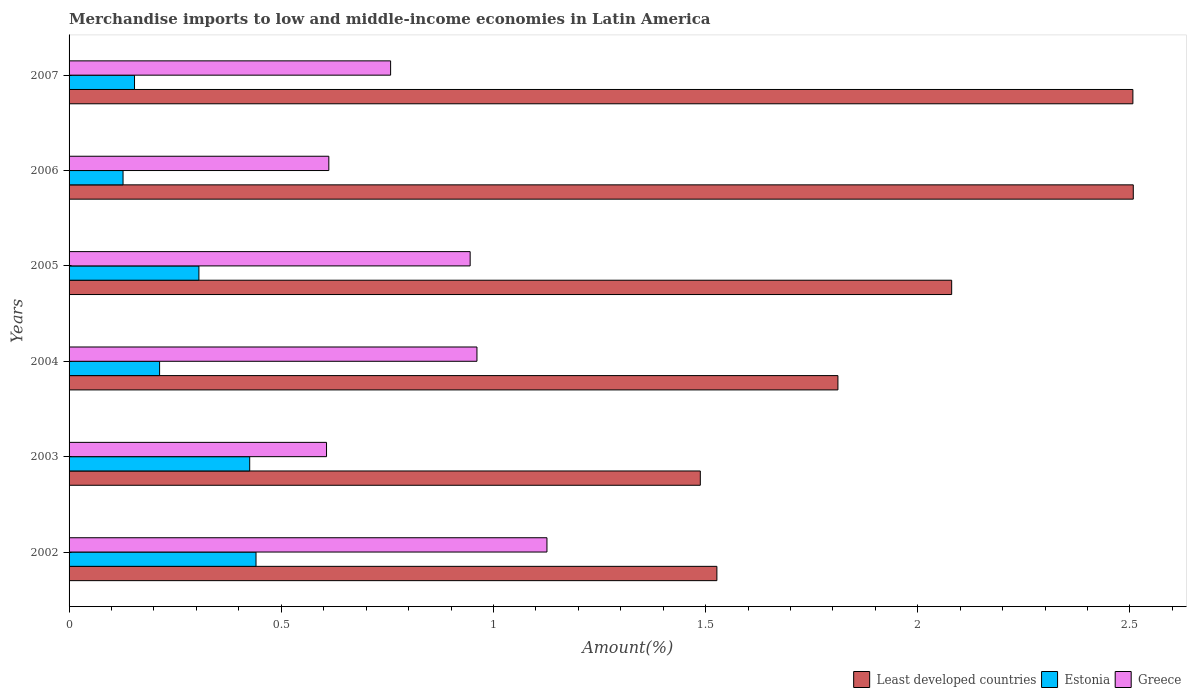How many different coloured bars are there?
Make the answer very short. 3. How many bars are there on the 5th tick from the top?
Make the answer very short. 3. How many bars are there on the 6th tick from the bottom?
Ensure brevity in your answer.  3. In how many cases, is the number of bars for a given year not equal to the number of legend labels?
Provide a short and direct response. 0. What is the percentage of amount earned from merchandise imports in Greece in 2005?
Your response must be concise. 0.95. Across all years, what is the maximum percentage of amount earned from merchandise imports in Estonia?
Give a very brief answer. 0.44. Across all years, what is the minimum percentage of amount earned from merchandise imports in Least developed countries?
Keep it short and to the point. 1.49. What is the total percentage of amount earned from merchandise imports in Least developed countries in the graph?
Offer a very short reply. 11.92. What is the difference between the percentage of amount earned from merchandise imports in Estonia in 2003 and that in 2006?
Keep it short and to the point. 0.3. What is the difference between the percentage of amount earned from merchandise imports in Greece in 2006 and the percentage of amount earned from merchandise imports in Least developed countries in 2007?
Ensure brevity in your answer.  -1.89. What is the average percentage of amount earned from merchandise imports in Greece per year?
Your answer should be very brief. 0.83. In the year 2004, what is the difference between the percentage of amount earned from merchandise imports in Estonia and percentage of amount earned from merchandise imports in Greece?
Keep it short and to the point. -0.75. In how many years, is the percentage of amount earned from merchandise imports in Least developed countries greater than 2.4 %?
Offer a very short reply. 2. What is the ratio of the percentage of amount earned from merchandise imports in Greece in 2002 to that in 2003?
Provide a short and direct response. 1.86. Is the percentage of amount earned from merchandise imports in Greece in 2005 less than that in 2007?
Ensure brevity in your answer.  No. What is the difference between the highest and the second highest percentage of amount earned from merchandise imports in Estonia?
Your answer should be compact. 0.01. What is the difference between the highest and the lowest percentage of amount earned from merchandise imports in Least developed countries?
Give a very brief answer. 1.02. In how many years, is the percentage of amount earned from merchandise imports in Estonia greater than the average percentage of amount earned from merchandise imports in Estonia taken over all years?
Make the answer very short. 3. Is the sum of the percentage of amount earned from merchandise imports in Least developed countries in 2003 and 2006 greater than the maximum percentage of amount earned from merchandise imports in Estonia across all years?
Your response must be concise. Yes. What does the 1st bar from the top in 2003 represents?
Your response must be concise. Greece. What does the 2nd bar from the bottom in 2005 represents?
Your answer should be compact. Estonia. Are all the bars in the graph horizontal?
Your answer should be very brief. Yes. How many years are there in the graph?
Your response must be concise. 6. What is the difference between two consecutive major ticks on the X-axis?
Provide a short and direct response. 0.5. Does the graph contain any zero values?
Provide a short and direct response. No. How many legend labels are there?
Your answer should be very brief. 3. How are the legend labels stacked?
Offer a very short reply. Horizontal. What is the title of the graph?
Ensure brevity in your answer.  Merchandise imports to low and middle-income economies in Latin America. Does "Belgium" appear as one of the legend labels in the graph?
Provide a succinct answer. No. What is the label or title of the X-axis?
Offer a very short reply. Amount(%). What is the label or title of the Y-axis?
Provide a short and direct response. Years. What is the Amount(%) in Least developed countries in 2002?
Make the answer very short. 1.53. What is the Amount(%) in Estonia in 2002?
Your response must be concise. 0.44. What is the Amount(%) of Greece in 2002?
Make the answer very short. 1.13. What is the Amount(%) in Least developed countries in 2003?
Give a very brief answer. 1.49. What is the Amount(%) of Estonia in 2003?
Give a very brief answer. 0.43. What is the Amount(%) in Greece in 2003?
Offer a terse response. 0.61. What is the Amount(%) of Least developed countries in 2004?
Keep it short and to the point. 1.81. What is the Amount(%) in Estonia in 2004?
Your answer should be compact. 0.21. What is the Amount(%) in Greece in 2004?
Provide a short and direct response. 0.96. What is the Amount(%) in Least developed countries in 2005?
Your response must be concise. 2.08. What is the Amount(%) in Estonia in 2005?
Make the answer very short. 0.31. What is the Amount(%) in Greece in 2005?
Provide a succinct answer. 0.95. What is the Amount(%) in Least developed countries in 2006?
Keep it short and to the point. 2.51. What is the Amount(%) in Estonia in 2006?
Give a very brief answer. 0.13. What is the Amount(%) in Greece in 2006?
Keep it short and to the point. 0.61. What is the Amount(%) of Least developed countries in 2007?
Provide a succinct answer. 2.51. What is the Amount(%) in Estonia in 2007?
Ensure brevity in your answer.  0.15. What is the Amount(%) of Greece in 2007?
Make the answer very short. 0.76. Across all years, what is the maximum Amount(%) in Least developed countries?
Keep it short and to the point. 2.51. Across all years, what is the maximum Amount(%) of Estonia?
Your answer should be very brief. 0.44. Across all years, what is the maximum Amount(%) in Greece?
Make the answer very short. 1.13. Across all years, what is the minimum Amount(%) in Least developed countries?
Keep it short and to the point. 1.49. Across all years, what is the minimum Amount(%) of Estonia?
Offer a very short reply. 0.13. Across all years, what is the minimum Amount(%) in Greece?
Provide a short and direct response. 0.61. What is the total Amount(%) in Least developed countries in the graph?
Your answer should be compact. 11.92. What is the total Amount(%) of Estonia in the graph?
Your answer should be very brief. 1.67. What is the total Amount(%) of Greece in the graph?
Provide a short and direct response. 5.01. What is the difference between the Amount(%) in Least developed countries in 2002 and that in 2003?
Your response must be concise. 0.04. What is the difference between the Amount(%) in Estonia in 2002 and that in 2003?
Make the answer very short. 0.01. What is the difference between the Amount(%) of Greece in 2002 and that in 2003?
Your answer should be very brief. 0.52. What is the difference between the Amount(%) of Least developed countries in 2002 and that in 2004?
Your response must be concise. -0.29. What is the difference between the Amount(%) of Estonia in 2002 and that in 2004?
Give a very brief answer. 0.23. What is the difference between the Amount(%) in Greece in 2002 and that in 2004?
Give a very brief answer. 0.17. What is the difference between the Amount(%) in Least developed countries in 2002 and that in 2005?
Keep it short and to the point. -0.55. What is the difference between the Amount(%) of Estonia in 2002 and that in 2005?
Your response must be concise. 0.13. What is the difference between the Amount(%) in Greece in 2002 and that in 2005?
Provide a succinct answer. 0.18. What is the difference between the Amount(%) in Least developed countries in 2002 and that in 2006?
Ensure brevity in your answer.  -0.98. What is the difference between the Amount(%) of Estonia in 2002 and that in 2006?
Your answer should be very brief. 0.31. What is the difference between the Amount(%) of Greece in 2002 and that in 2006?
Provide a succinct answer. 0.51. What is the difference between the Amount(%) in Least developed countries in 2002 and that in 2007?
Your response must be concise. -0.98. What is the difference between the Amount(%) in Estonia in 2002 and that in 2007?
Provide a succinct answer. 0.29. What is the difference between the Amount(%) of Greece in 2002 and that in 2007?
Give a very brief answer. 0.37. What is the difference between the Amount(%) of Least developed countries in 2003 and that in 2004?
Your response must be concise. -0.32. What is the difference between the Amount(%) in Estonia in 2003 and that in 2004?
Your response must be concise. 0.21. What is the difference between the Amount(%) in Greece in 2003 and that in 2004?
Your answer should be very brief. -0.35. What is the difference between the Amount(%) in Least developed countries in 2003 and that in 2005?
Offer a terse response. -0.59. What is the difference between the Amount(%) of Estonia in 2003 and that in 2005?
Offer a terse response. 0.12. What is the difference between the Amount(%) in Greece in 2003 and that in 2005?
Give a very brief answer. -0.34. What is the difference between the Amount(%) in Least developed countries in 2003 and that in 2006?
Your answer should be compact. -1.02. What is the difference between the Amount(%) in Estonia in 2003 and that in 2006?
Make the answer very short. 0.3. What is the difference between the Amount(%) of Greece in 2003 and that in 2006?
Make the answer very short. -0.01. What is the difference between the Amount(%) in Least developed countries in 2003 and that in 2007?
Your response must be concise. -1.02. What is the difference between the Amount(%) of Estonia in 2003 and that in 2007?
Provide a short and direct response. 0.27. What is the difference between the Amount(%) in Greece in 2003 and that in 2007?
Offer a very short reply. -0.15. What is the difference between the Amount(%) in Least developed countries in 2004 and that in 2005?
Give a very brief answer. -0.27. What is the difference between the Amount(%) in Estonia in 2004 and that in 2005?
Provide a succinct answer. -0.09. What is the difference between the Amount(%) of Greece in 2004 and that in 2005?
Provide a succinct answer. 0.02. What is the difference between the Amount(%) of Least developed countries in 2004 and that in 2006?
Provide a short and direct response. -0.7. What is the difference between the Amount(%) in Estonia in 2004 and that in 2006?
Give a very brief answer. 0.09. What is the difference between the Amount(%) in Greece in 2004 and that in 2006?
Offer a very short reply. 0.35. What is the difference between the Amount(%) of Least developed countries in 2004 and that in 2007?
Offer a terse response. -0.7. What is the difference between the Amount(%) of Estonia in 2004 and that in 2007?
Keep it short and to the point. 0.06. What is the difference between the Amount(%) of Greece in 2004 and that in 2007?
Provide a short and direct response. 0.2. What is the difference between the Amount(%) of Least developed countries in 2005 and that in 2006?
Provide a succinct answer. -0.43. What is the difference between the Amount(%) of Estonia in 2005 and that in 2006?
Provide a succinct answer. 0.18. What is the difference between the Amount(%) in Greece in 2005 and that in 2006?
Your answer should be compact. 0.33. What is the difference between the Amount(%) of Least developed countries in 2005 and that in 2007?
Your response must be concise. -0.43. What is the difference between the Amount(%) of Estonia in 2005 and that in 2007?
Offer a very short reply. 0.15. What is the difference between the Amount(%) of Greece in 2005 and that in 2007?
Your answer should be very brief. 0.19. What is the difference between the Amount(%) of Least developed countries in 2006 and that in 2007?
Give a very brief answer. 0. What is the difference between the Amount(%) of Estonia in 2006 and that in 2007?
Your answer should be very brief. -0.03. What is the difference between the Amount(%) in Greece in 2006 and that in 2007?
Offer a very short reply. -0.15. What is the difference between the Amount(%) in Least developed countries in 2002 and the Amount(%) in Estonia in 2003?
Make the answer very short. 1.1. What is the difference between the Amount(%) of Least developed countries in 2002 and the Amount(%) of Greece in 2003?
Your answer should be very brief. 0.92. What is the difference between the Amount(%) in Estonia in 2002 and the Amount(%) in Greece in 2003?
Ensure brevity in your answer.  -0.17. What is the difference between the Amount(%) of Least developed countries in 2002 and the Amount(%) of Estonia in 2004?
Offer a terse response. 1.31. What is the difference between the Amount(%) in Least developed countries in 2002 and the Amount(%) in Greece in 2004?
Keep it short and to the point. 0.57. What is the difference between the Amount(%) of Estonia in 2002 and the Amount(%) of Greece in 2004?
Provide a succinct answer. -0.52. What is the difference between the Amount(%) of Least developed countries in 2002 and the Amount(%) of Estonia in 2005?
Your response must be concise. 1.22. What is the difference between the Amount(%) in Least developed countries in 2002 and the Amount(%) in Greece in 2005?
Make the answer very short. 0.58. What is the difference between the Amount(%) of Estonia in 2002 and the Amount(%) of Greece in 2005?
Keep it short and to the point. -0.5. What is the difference between the Amount(%) of Least developed countries in 2002 and the Amount(%) of Estonia in 2006?
Your answer should be very brief. 1.4. What is the difference between the Amount(%) of Least developed countries in 2002 and the Amount(%) of Greece in 2006?
Provide a short and direct response. 0.91. What is the difference between the Amount(%) of Estonia in 2002 and the Amount(%) of Greece in 2006?
Offer a very short reply. -0.17. What is the difference between the Amount(%) in Least developed countries in 2002 and the Amount(%) in Estonia in 2007?
Make the answer very short. 1.37. What is the difference between the Amount(%) of Least developed countries in 2002 and the Amount(%) of Greece in 2007?
Make the answer very short. 0.77. What is the difference between the Amount(%) of Estonia in 2002 and the Amount(%) of Greece in 2007?
Provide a short and direct response. -0.32. What is the difference between the Amount(%) of Least developed countries in 2003 and the Amount(%) of Estonia in 2004?
Your answer should be very brief. 1.27. What is the difference between the Amount(%) in Least developed countries in 2003 and the Amount(%) in Greece in 2004?
Give a very brief answer. 0.53. What is the difference between the Amount(%) of Estonia in 2003 and the Amount(%) of Greece in 2004?
Your response must be concise. -0.54. What is the difference between the Amount(%) of Least developed countries in 2003 and the Amount(%) of Estonia in 2005?
Keep it short and to the point. 1.18. What is the difference between the Amount(%) in Least developed countries in 2003 and the Amount(%) in Greece in 2005?
Offer a terse response. 0.54. What is the difference between the Amount(%) in Estonia in 2003 and the Amount(%) in Greece in 2005?
Make the answer very short. -0.52. What is the difference between the Amount(%) of Least developed countries in 2003 and the Amount(%) of Estonia in 2006?
Your answer should be very brief. 1.36. What is the difference between the Amount(%) in Least developed countries in 2003 and the Amount(%) in Greece in 2006?
Offer a very short reply. 0.88. What is the difference between the Amount(%) of Estonia in 2003 and the Amount(%) of Greece in 2006?
Make the answer very short. -0.19. What is the difference between the Amount(%) in Least developed countries in 2003 and the Amount(%) in Greece in 2007?
Offer a very short reply. 0.73. What is the difference between the Amount(%) in Estonia in 2003 and the Amount(%) in Greece in 2007?
Ensure brevity in your answer.  -0.33. What is the difference between the Amount(%) in Least developed countries in 2004 and the Amount(%) in Estonia in 2005?
Offer a very short reply. 1.51. What is the difference between the Amount(%) of Least developed countries in 2004 and the Amount(%) of Greece in 2005?
Your response must be concise. 0.87. What is the difference between the Amount(%) in Estonia in 2004 and the Amount(%) in Greece in 2005?
Your answer should be very brief. -0.73. What is the difference between the Amount(%) of Least developed countries in 2004 and the Amount(%) of Estonia in 2006?
Keep it short and to the point. 1.68. What is the difference between the Amount(%) of Least developed countries in 2004 and the Amount(%) of Greece in 2006?
Ensure brevity in your answer.  1.2. What is the difference between the Amount(%) in Estonia in 2004 and the Amount(%) in Greece in 2006?
Your answer should be compact. -0.4. What is the difference between the Amount(%) of Least developed countries in 2004 and the Amount(%) of Estonia in 2007?
Your response must be concise. 1.66. What is the difference between the Amount(%) in Least developed countries in 2004 and the Amount(%) in Greece in 2007?
Provide a succinct answer. 1.05. What is the difference between the Amount(%) in Estonia in 2004 and the Amount(%) in Greece in 2007?
Give a very brief answer. -0.54. What is the difference between the Amount(%) in Least developed countries in 2005 and the Amount(%) in Estonia in 2006?
Offer a very short reply. 1.95. What is the difference between the Amount(%) of Least developed countries in 2005 and the Amount(%) of Greece in 2006?
Your answer should be compact. 1.47. What is the difference between the Amount(%) of Estonia in 2005 and the Amount(%) of Greece in 2006?
Provide a short and direct response. -0.31. What is the difference between the Amount(%) of Least developed countries in 2005 and the Amount(%) of Estonia in 2007?
Offer a very short reply. 1.93. What is the difference between the Amount(%) in Least developed countries in 2005 and the Amount(%) in Greece in 2007?
Your response must be concise. 1.32. What is the difference between the Amount(%) of Estonia in 2005 and the Amount(%) of Greece in 2007?
Your response must be concise. -0.45. What is the difference between the Amount(%) in Least developed countries in 2006 and the Amount(%) in Estonia in 2007?
Make the answer very short. 2.35. What is the difference between the Amount(%) of Least developed countries in 2006 and the Amount(%) of Greece in 2007?
Offer a terse response. 1.75. What is the difference between the Amount(%) in Estonia in 2006 and the Amount(%) in Greece in 2007?
Provide a short and direct response. -0.63. What is the average Amount(%) of Least developed countries per year?
Your answer should be very brief. 1.99. What is the average Amount(%) of Estonia per year?
Offer a very short reply. 0.28. What is the average Amount(%) in Greece per year?
Keep it short and to the point. 0.83. In the year 2002, what is the difference between the Amount(%) in Least developed countries and Amount(%) in Estonia?
Your answer should be very brief. 1.09. In the year 2002, what is the difference between the Amount(%) of Least developed countries and Amount(%) of Greece?
Offer a terse response. 0.4. In the year 2002, what is the difference between the Amount(%) in Estonia and Amount(%) in Greece?
Give a very brief answer. -0.69. In the year 2003, what is the difference between the Amount(%) in Least developed countries and Amount(%) in Estonia?
Offer a terse response. 1.06. In the year 2003, what is the difference between the Amount(%) of Least developed countries and Amount(%) of Greece?
Provide a short and direct response. 0.88. In the year 2003, what is the difference between the Amount(%) of Estonia and Amount(%) of Greece?
Your answer should be very brief. -0.18. In the year 2004, what is the difference between the Amount(%) in Least developed countries and Amount(%) in Estonia?
Provide a short and direct response. 1.6. In the year 2004, what is the difference between the Amount(%) in Least developed countries and Amount(%) in Greece?
Your response must be concise. 0.85. In the year 2004, what is the difference between the Amount(%) in Estonia and Amount(%) in Greece?
Your response must be concise. -0.75. In the year 2005, what is the difference between the Amount(%) of Least developed countries and Amount(%) of Estonia?
Provide a succinct answer. 1.77. In the year 2005, what is the difference between the Amount(%) of Least developed countries and Amount(%) of Greece?
Provide a short and direct response. 1.13. In the year 2005, what is the difference between the Amount(%) in Estonia and Amount(%) in Greece?
Offer a very short reply. -0.64. In the year 2006, what is the difference between the Amount(%) in Least developed countries and Amount(%) in Estonia?
Offer a very short reply. 2.38. In the year 2006, what is the difference between the Amount(%) of Least developed countries and Amount(%) of Greece?
Your answer should be very brief. 1.9. In the year 2006, what is the difference between the Amount(%) of Estonia and Amount(%) of Greece?
Provide a succinct answer. -0.48. In the year 2007, what is the difference between the Amount(%) of Least developed countries and Amount(%) of Estonia?
Your answer should be very brief. 2.35. In the year 2007, what is the difference between the Amount(%) of Least developed countries and Amount(%) of Greece?
Keep it short and to the point. 1.75. In the year 2007, what is the difference between the Amount(%) in Estonia and Amount(%) in Greece?
Your answer should be compact. -0.6. What is the ratio of the Amount(%) of Least developed countries in 2002 to that in 2003?
Your answer should be very brief. 1.03. What is the ratio of the Amount(%) in Estonia in 2002 to that in 2003?
Give a very brief answer. 1.03. What is the ratio of the Amount(%) of Greece in 2002 to that in 2003?
Ensure brevity in your answer.  1.86. What is the ratio of the Amount(%) of Least developed countries in 2002 to that in 2004?
Your response must be concise. 0.84. What is the ratio of the Amount(%) in Estonia in 2002 to that in 2004?
Offer a very short reply. 2.07. What is the ratio of the Amount(%) in Greece in 2002 to that in 2004?
Provide a succinct answer. 1.17. What is the ratio of the Amount(%) of Least developed countries in 2002 to that in 2005?
Offer a very short reply. 0.73. What is the ratio of the Amount(%) in Estonia in 2002 to that in 2005?
Offer a very short reply. 1.44. What is the ratio of the Amount(%) in Greece in 2002 to that in 2005?
Your answer should be compact. 1.19. What is the ratio of the Amount(%) in Least developed countries in 2002 to that in 2006?
Make the answer very short. 0.61. What is the ratio of the Amount(%) of Estonia in 2002 to that in 2006?
Your answer should be compact. 3.46. What is the ratio of the Amount(%) of Greece in 2002 to that in 2006?
Keep it short and to the point. 1.84. What is the ratio of the Amount(%) of Least developed countries in 2002 to that in 2007?
Your response must be concise. 0.61. What is the ratio of the Amount(%) of Estonia in 2002 to that in 2007?
Offer a terse response. 2.86. What is the ratio of the Amount(%) in Greece in 2002 to that in 2007?
Keep it short and to the point. 1.49. What is the ratio of the Amount(%) of Least developed countries in 2003 to that in 2004?
Keep it short and to the point. 0.82. What is the ratio of the Amount(%) in Estonia in 2003 to that in 2004?
Your answer should be very brief. 2. What is the ratio of the Amount(%) in Greece in 2003 to that in 2004?
Ensure brevity in your answer.  0.63. What is the ratio of the Amount(%) in Least developed countries in 2003 to that in 2005?
Provide a short and direct response. 0.72. What is the ratio of the Amount(%) of Estonia in 2003 to that in 2005?
Provide a short and direct response. 1.39. What is the ratio of the Amount(%) in Greece in 2003 to that in 2005?
Your response must be concise. 0.64. What is the ratio of the Amount(%) in Least developed countries in 2003 to that in 2006?
Ensure brevity in your answer.  0.59. What is the ratio of the Amount(%) in Estonia in 2003 to that in 2006?
Provide a succinct answer. 3.35. What is the ratio of the Amount(%) of Greece in 2003 to that in 2006?
Offer a very short reply. 0.99. What is the ratio of the Amount(%) in Least developed countries in 2003 to that in 2007?
Offer a terse response. 0.59. What is the ratio of the Amount(%) in Estonia in 2003 to that in 2007?
Your answer should be compact. 2.76. What is the ratio of the Amount(%) of Greece in 2003 to that in 2007?
Make the answer very short. 0.8. What is the ratio of the Amount(%) in Least developed countries in 2004 to that in 2005?
Provide a succinct answer. 0.87. What is the ratio of the Amount(%) of Estonia in 2004 to that in 2005?
Your answer should be compact. 0.7. What is the ratio of the Amount(%) of Least developed countries in 2004 to that in 2006?
Provide a succinct answer. 0.72. What is the ratio of the Amount(%) of Estonia in 2004 to that in 2006?
Give a very brief answer. 1.68. What is the ratio of the Amount(%) of Greece in 2004 to that in 2006?
Give a very brief answer. 1.57. What is the ratio of the Amount(%) in Least developed countries in 2004 to that in 2007?
Your response must be concise. 0.72. What is the ratio of the Amount(%) of Estonia in 2004 to that in 2007?
Provide a succinct answer. 1.38. What is the ratio of the Amount(%) of Greece in 2004 to that in 2007?
Your answer should be compact. 1.27. What is the ratio of the Amount(%) of Least developed countries in 2005 to that in 2006?
Offer a terse response. 0.83. What is the ratio of the Amount(%) in Estonia in 2005 to that in 2006?
Your answer should be compact. 2.41. What is the ratio of the Amount(%) in Greece in 2005 to that in 2006?
Provide a short and direct response. 1.54. What is the ratio of the Amount(%) of Least developed countries in 2005 to that in 2007?
Give a very brief answer. 0.83. What is the ratio of the Amount(%) of Estonia in 2005 to that in 2007?
Provide a short and direct response. 1.98. What is the ratio of the Amount(%) in Greece in 2005 to that in 2007?
Provide a short and direct response. 1.25. What is the ratio of the Amount(%) in Estonia in 2006 to that in 2007?
Provide a short and direct response. 0.82. What is the ratio of the Amount(%) of Greece in 2006 to that in 2007?
Offer a very short reply. 0.81. What is the difference between the highest and the second highest Amount(%) in Least developed countries?
Make the answer very short. 0. What is the difference between the highest and the second highest Amount(%) of Estonia?
Keep it short and to the point. 0.01. What is the difference between the highest and the second highest Amount(%) of Greece?
Ensure brevity in your answer.  0.17. What is the difference between the highest and the lowest Amount(%) of Least developed countries?
Your answer should be very brief. 1.02. What is the difference between the highest and the lowest Amount(%) of Estonia?
Ensure brevity in your answer.  0.31. What is the difference between the highest and the lowest Amount(%) of Greece?
Your answer should be very brief. 0.52. 